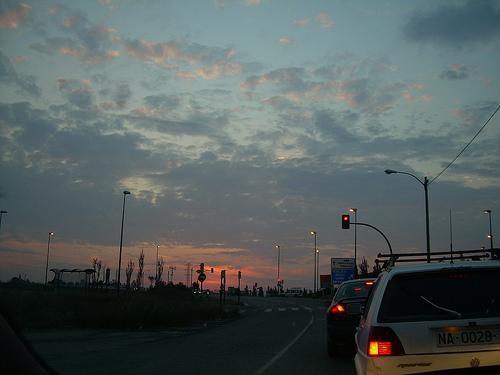How many cars are to the right?
Give a very brief answer. 2. 